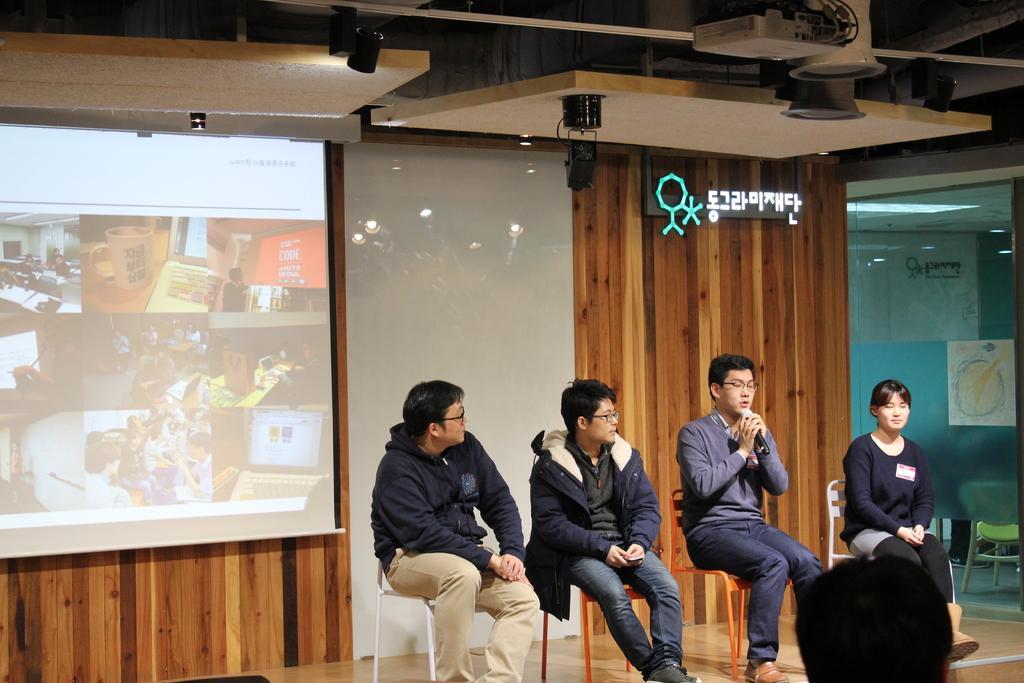Can you describe this image briefly? In this image on the right, there is a woman, she wears a t shirt, trouser, shoes, she is sitting and there is a man, he wears a t shirt, trouser, shoes, he is sitting, he is holding a mic. In the middle there is a man, he wears a jacket, shirt, trouser, shoes, he is sitting and there is a man, he wears a jacket, trouser, he is sitting. On the left there is a screen. At the bottom there are people. In the background there are lights, text, glass, chairs and floor. 